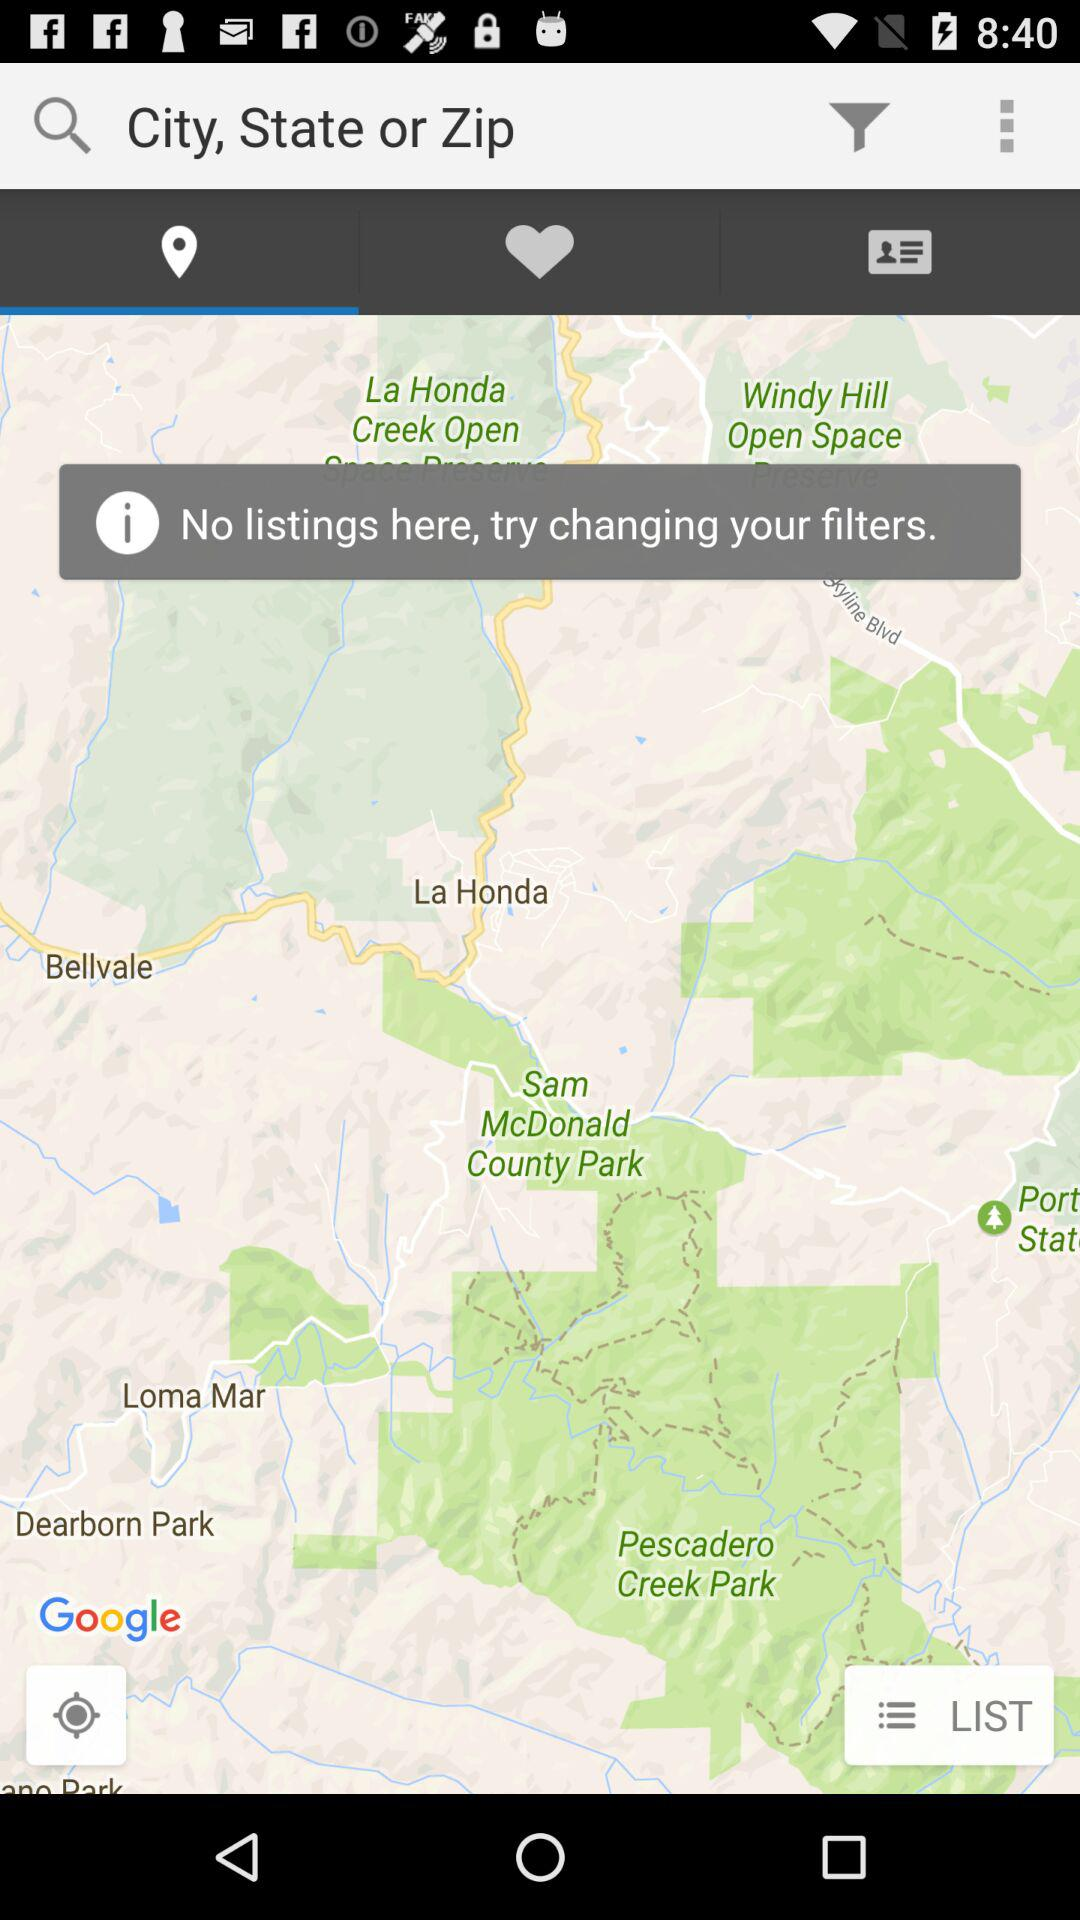Which tab is selected? The selected tab is "Locations". 